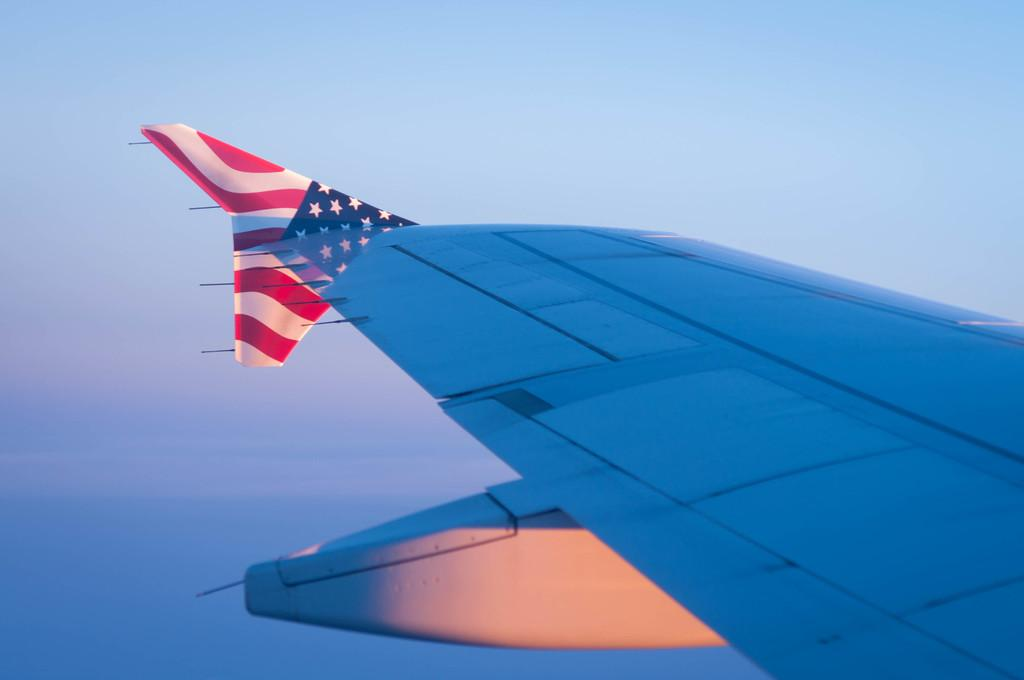What is the main subject of the image? The main subject of the image is an aeroplane wing. What can be seen in the background of the image? The sky is visible in the image. Where is the vase located in the image? There is no vase present in the image. What type of insect can be seen crawling on the aeroplane wing in the image? There are no insects visible on the aeroplane wing in the image. 